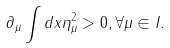Convert formula to latex. <formula><loc_0><loc_0><loc_500><loc_500>\partial _ { \mu } \int d x \eta _ { \mu } ^ { 2 } > 0 , \forall \mu \in I .</formula> 